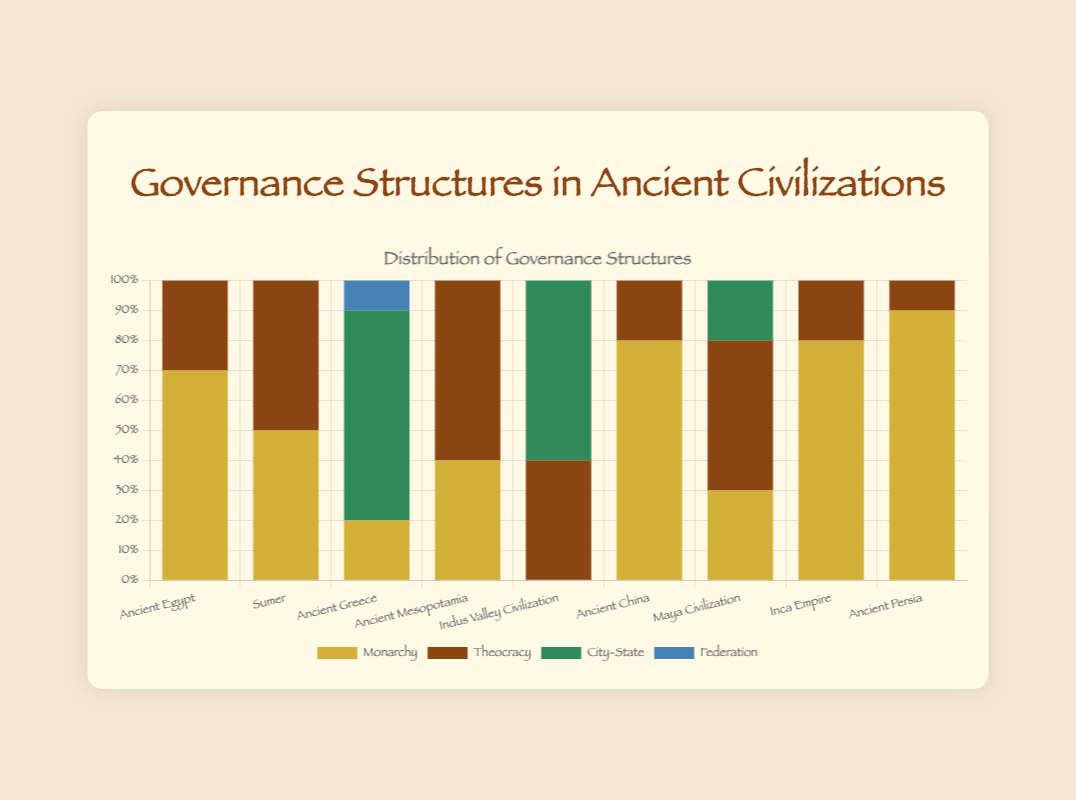Which civilization used monarchy the most? The bars in the stacked bar chart show that Ancient Persia has the highest proportion of monarchy, with 0.9 or 90%.
Answer: Ancient Persia Which civilizations used a combination of monarchy and theocracy? Checking the stacked bar chart, we see that Ancient Egypt, Sumer, Ancient Mesopotamia, Ancient China, Maya Civilization, and Inca Empire have both monarchy and theocracy governance structures to varying extents.
Answer: Ancient Egypt, Sumer, Ancient Mesopotamia, Ancient China, Maya Civilization, Inca Empire Comparing Ancient China and the Inca Empire, which civilization relied more heavily on monarchy? The chart shows the bar height for monarchy as 0.8 (80%) for both Ancient China and the Inca Empire. Hence, they had an equal reliance on monarchy.
Answer: Same What is the combined proportion of monarchy and theocracy in Ancient Greece? Referring to the bar heights, the proportion for monarchy is 0.2 and for theocracy is 0. Combining these, 0.2 + 0 = 0.2 or 20%.
Answer: 0.2 or 20% Which civilization had the highest proportion of city-states? From the stacked bar chart, Ancient Greece has the tallest bar for city-states with 0.7 or 70%.
Answer: Ancient Greece How many civilizations used federations as part of their governance structure? The chart only indicates a proportion for federation in Ancient Greece with a value of 0.1 or 10%.
Answer: 1 Which civilizations have no representation of monarchy in their governance structure? The bars for monarchy in Indus Valley Civilization show a height of 0, indicating no monarchy structure.
Answer: Indus Valley Civilization In terms of visual representation, what does the color dark green signify in the chart? Observing the color legend at the bottom of the chart, dark green corresponds to city-states.
Answer: City-State Which civilization has the most balanced mix of monarchy and theocracy? Analyzing the differences in bar heights for monarchy and theocracy, Sumer shows an equal split of 0.5 (50%) each.
Answer: Sumer Which civilizations relied primarily on theocracy? From the data shown, we see that Ancient Mesopotamia's bar for theocracy is at 0.6, and the Indus Valley Civilization has its theocracy bar at 0.4. These are the most significant proportions, indicating primary reliance.
Answer: Ancient Mesopotamia, Indus Valley Civilization 